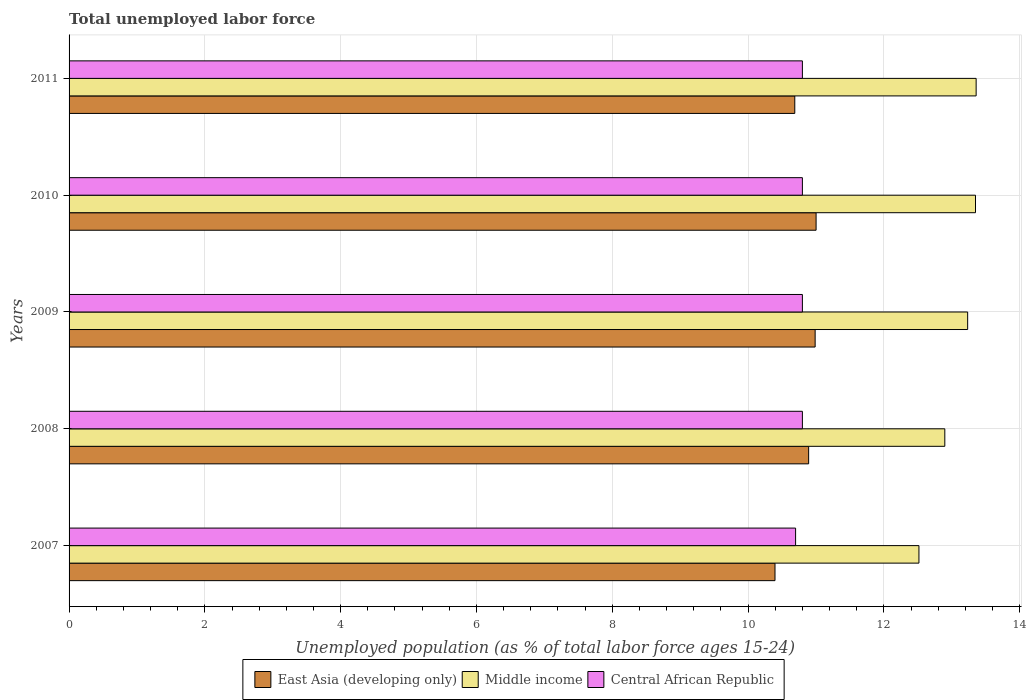How many different coloured bars are there?
Your answer should be very brief. 3. Are the number of bars on each tick of the Y-axis equal?
Offer a very short reply. Yes. How many bars are there on the 4th tick from the bottom?
Keep it short and to the point. 3. In how many cases, is the number of bars for a given year not equal to the number of legend labels?
Offer a very short reply. 0. What is the percentage of unemployed population in in Central African Republic in 2011?
Your answer should be compact. 10.8. Across all years, what is the maximum percentage of unemployed population in in East Asia (developing only)?
Your answer should be compact. 11. Across all years, what is the minimum percentage of unemployed population in in East Asia (developing only)?
Provide a succinct answer. 10.4. In which year was the percentage of unemployed population in in Central African Republic maximum?
Your answer should be very brief. 2008. In which year was the percentage of unemployed population in in Central African Republic minimum?
Keep it short and to the point. 2007. What is the total percentage of unemployed population in in Middle income in the graph?
Provide a short and direct response. 65.36. What is the difference between the percentage of unemployed population in in East Asia (developing only) in 2007 and that in 2008?
Provide a succinct answer. -0.5. What is the difference between the percentage of unemployed population in in Middle income in 2010 and the percentage of unemployed population in in Central African Republic in 2009?
Provide a short and direct response. 2.55. What is the average percentage of unemployed population in in Central African Republic per year?
Your response must be concise. 10.78. In the year 2007, what is the difference between the percentage of unemployed population in in Middle income and percentage of unemployed population in in Central African Republic?
Offer a terse response. 1.82. What is the ratio of the percentage of unemployed population in in Central African Republic in 2007 to that in 2010?
Offer a very short reply. 0.99. Is the percentage of unemployed population in in East Asia (developing only) in 2008 less than that in 2011?
Provide a succinct answer. No. What is the difference between the highest and the second highest percentage of unemployed population in in Middle income?
Ensure brevity in your answer.  0.01. What is the difference between the highest and the lowest percentage of unemployed population in in Middle income?
Make the answer very short. 0.84. What does the 3rd bar from the top in 2010 represents?
Your answer should be very brief. East Asia (developing only). What does the 2nd bar from the bottom in 2011 represents?
Keep it short and to the point. Middle income. How many bars are there?
Give a very brief answer. 15. Are all the bars in the graph horizontal?
Make the answer very short. Yes. What is the difference between two consecutive major ticks on the X-axis?
Provide a short and direct response. 2. Does the graph contain any zero values?
Offer a terse response. No. Where does the legend appear in the graph?
Give a very brief answer. Bottom center. How are the legend labels stacked?
Give a very brief answer. Horizontal. What is the title of the graph?
Give a very brief answer. Total unemployed labor force. What is the label or title of the X-axis?
Your answer should be compact. Unemployed population (as % of total labor force ages 15-24). What is the label or title of the Y-axis?
Give a very brief answer. Years. What is the Unemployed population (as % of total labor force ages 15-24) of East Asia (developing only) in 2007?
Make the answer very short. 10.4. What is the Unemployed population (as % of total labor force ages 15-24) of Middle income in 2007?
Keep it short and to the point. 12.52. What is the Unemployed population (as % of total labor force ages 15-24) of Central African Republic in 2007?
Give a very brief answer. 10.7. What is the Unemployed population (as % of total labor force ages 15-24) of East Asia (developing only) in 2008?
Your answer should be very brief. 10.89. What is the Unemployed population (as % of total labor force ages 15-24) in Middle income in 2008?
Offer a terse response. 12.9. What is the Unemployed population (as % of total labor force ages 15-24) of Central African Republic in 2008?
Your answer should be compact. 10.8. What is the Unemployed population (as % of total labor force ages 15-24) in East Asia (developing only) in 2009?
Your answer should be compact. 10.99. What is the Unemployed population (as % of total labor force ages 15-24) of Middle income in 2009?
Provide a short and direct response. 13.23. What is the Unemployed population (as % of total labor force ages 15-24) in Central African Republic in 2009?
Make the answer very short. 10.8. What is the Unemployed population (as % of total labor force ages 15-24) in East Asia (developing only) in 2010?
Provide a short and direct response. 11. What is the Unemployed population (as % of total labor force ages 15-24) in Middle income in 2010?
Make the answer very short. 13.35. What is the Unemployed population (as % of total labor force ages 15-24) in Central African Republic in 2010?
Offer a very short reply. 10.8. What is the Unemployed population (as % of total labor force ages 15-24) of East Asia (developing only) in 2011?
Your answer should be very brief. 10.69. What is the Unemployed population (as % of total labor force ages 15-24) of Middle income in 2011?
Keep it short and to the point. 13.36. What is the Unemployed population (as % of total labor force ages 15-24) in Central African Republic in 2011?
Give a very brief answer. 10.8. Across all years, what is the maximum Unemployed population (as % of total labor force ages 15-24) in East Asia (developing only)?
Ensure brevity in your answer.  11. Across all years, what is the maximum Unemployed population (as % of total labor force ages 15-24) in Middle income?
Give a very brief answer. 13.36. Across all years, what is the maximum Unemployed population (as % of total labor force ages 15-24) in Central African Republic?
Offer a very short reply. 10.8. Across all years, what is the minimum Unemployed population (as % of total labor force ages 15-24) in East Asia (developing only)?
Provide a short and direct response. 10.4. Across all years, what is the minimum Unemployed population (as % of total labor force ages 15-24) of Middle income?
Ensure brevity in your answer.  12.52. Across all years, what is the minimum Unemployed population (as % of total labor force ages 15-24) in Central African Republic?
Provide a succinct answer. 10.7. What is the total Unemployed population (as % of total labor force ages 15-24) in East Asia (developing only) in the graph?
Make the answer very short. 53.97. What is the total Unemployed population (as % of total labor force ages 15-24) of Middle income in the graph?
Keep it short and to the point. 65.36. What is the total Unemployed population (as % of total labor force ages 15-24) of Central African Republic in the graph?
Ensure brevity in your answer.  53.9. What is the difference between the Unemployed population (as % of total labor force ages 15-24) of East Asia (developing only) in 2007 and that in 2008?
Ensure brevity in your answer.  -0.5. What is the difference between the Unemployed population (as % of total labor force ages 15-24) of Middle income in 2007 and that in 2008?
Offer a very short reply. -0.38. What is the difference between the Unemployed population (as % of total labor force ages 15-24) in East Asia (developing only) in 2007 and that in 2009?
Offer a terse response. -0.59. What is the difference between the Unemployed population (as % of total labor force ages 15-24) of Middle income in 2007 and that in 2009?
Offer a very short reply. -0.72. What is the difference between the Unemployed population (as % of total labor force ages 15-24) of Central African Republic in 2007 and that in 2009?
Give a very brief answer. -0.1. What is the difference between the Unemployed population (as % of total labor force ages 15-24) in East Asia (developing only) in 2007 and that in 2010?
Your response must be concise. -0.61. What is the difference between the Unemployed population (as % of total labor force ages 15-24) in Middle income in 2007 and that in 2010?
Give a very brief answer. -0.83. What is the difference between the Unemployed population (as % of total labor force ages 15-24) of Central African Republic in 2007 and that in 2010?
Provide a short and direct response. -0.1. What is the difference between the Unemployed population (as % of total labor force ages 15-24) in East Asia (developing only) in 2007 and that in 2011?
Your answer should be very brief. -0.29. What is the difference between the Unemployed population (as % of total labor force ages 15-24) in Middle income in 2007 and that in 2011?
Keep it short and to the point. -0.84. What is the difference between the Unemployed population (as % of total labor force ages 15-24) of Central African Republic in 2007 and that in 2011?
Keep it short and to the point. -0.1. What is the difference between the Unemployed population (as % of total labor force ages 15-24) of East Asia (developing only) in 2008 and that in 2009?
Offer a very short reply. -0.1. What is the difference between the Unemployed population (as % of total labor force ages 15-24) in Middle income in 2008 and that in 2009?
Your answer should be compact. -0.34. What is the difference between the Unemployed population (as % of total labor force ages 15-24) in East Asia (developing only) in 2008 and that in 2010?
Your answer should be very brief. -0.11. What is the difference between the Unemployed population (as % of total labor force ages 15-24) in Middle income in 2008 and that in 2010?
Your response must be concise. -0.45. What is the difference between the Unemployed population (as % of total labor force ages 15-24) of Central African Republic in 2008 and that in 2010?
Offer a very short reply. 0. What is the difference between the Unemployed population (as % of total labor force ages 15-24) in East Asia (developing only) in 2008 and that in 2011?
Provide a succinct answer. 0.2. What is the difference between the Unemployed population (as % of total labor force ages 15-24) in Middle income in 2008 and that in 2011?
Ensure brevity in your answer.  -0.46. What is the difference between the Unemployed population (as % of total labor force ages 15-24) in East Asia (developing only) in 2009 and that in 2010?
Provide a short and direct response. -0.01. What is the difference between the Unemployed population (as % of total labor force ages 15-24) of Middle income in 2009 and that in 2010?
Your answer should be compact. -0.12. What is the difference between the Unemployed population (as % of total labor force ages 15-24) in Central African Republic in 2009 and that in 2010?
Provide a short and direct response. 0. What is the difference between the Unemployed population (as % of total labor force ages 15-24) in East Asia (developing only) in 2009 and that in 2011?
Provide a succinct answer. 0.3. What is the difference between the Unemployed population (as % of total labor force ages 15-24) in Middle income in 2009 and that in 2011?
Offer a very short reply. -0.12. What is the difference between the Unemployed population (as % of total labor force ages 15-24) of Central African Republic in 2009 and that in 2011?
Your answer should be very brief. 0. What is the difference between the Unemployed population (as % of total labor force ages 15-24) of East Asia (developing only) in 2010 and that in 2011?
Make the answer very short. 0.31. What is the difference between the Unemployed population (as % of total labor force ages 15-24) of Middle income in 2010 and that in 2011?
Offer a very short reply. -0.01. What is the difference between the Unemployed population (as % of total labor force ages 15-24) of Central African Republic in 2010 and that in 2011?
Offer a very short reply. 0. What is the difference between the Unemployed population (as % of total labor force ages 15-24) in East Asia (developing only) in 2007 and the Unemployed population (as % of total labor force ages 15-24) in Middle income in 2008?
Ensure brevity in your answer.  -2.5. What is the difference between the Unemployed population (as % of total labor force ages 15-24) in East Asia (developing only) in 2007 and the Unemployed population (as % of total labor force ages 15-24) in Central African Republic in 2008?
Your response must be concise. -0.4. What is the difference between the Unemployed population (as % of total labor force ages 15-24) of Middle income in 2007 and the Unemployed population (as % of total labor force ages 15-24) of Central African Republic in 2008?
Your answer should be very brief. 1.72. What is the difference between the Unemployed population (as % of total labor force ages 15-24) in East Asia (developing only) in 2007 and the Unemployed population (as % of total labor force ages 15-24) in Middle income in 2009?
Provide a short and direct response. -2.84. What is the difference between the Unemployed population (as % of total labor force ages 15-24) of East Asia (developing only) in 2007 and the Unemployed population (as % of total labor force ages 15-24) of Central African Republic in 2009?
Ensure brevity in your answer.  -0.4. What is the difference between the Unemployed population (as % of total labor force ages 15-24) in Middle income in 2007 and the Unemployed population (as % of total labor force ages 15-24) in Central African Republic in 2009?
Provide a short and direct response. 1.72. What is the difference between the Unemployed population (as % of total labor force ages 15-24) of East Asia (developing only) in 2007 and the Unemployed population (as % of total labor force ages 15-24) of Middle income in 2010?
Ensure brevity in your answer.  -2.95. What is the difference between the Unemployed population (as % of total labor force ages 15-24) in East Asia (developing only) in 2007 and the Unemployed population (as % of total labor force ages 15-24) in Central African Republic in 2010?
Offer a terse response. -0.4. What is the difference between the Unemployed population (as % of total labor force ages 15-24) of Middle income in 2007 and the Unemployed population (as % of total labor force ages 15-24) of Central African Republic in 2010?
Provide a succinct answer. 1.72. What is the difference between the Unemployed population (as % of total labor force ages 15-24) of East Asia (developing only) in 2007 and the Unemployed population (as % of total labor force ages 15-24) of Middle income in 2011?
Provide a succinct answer. -2.96. What is the difference between the Unemployed population (as % of total labor force ages 15-24) in East Asia (developing only) in 2007 and the Unemployed population (as % of total labor force ages 15-24) in Central African Republic in 2011?
Offer a very short reply. -0.4. What is the difference between the Unemployed population (as % of total labor force ages 15-24) of Middle income in 2007 and the Unemployed population (as % of total labor force ages 15-24) of Central African Republic in 2011?
Offer a terse response. 1.72. What is the difference between the Unemployed population (as % of total labor force ages 15-24) of East Asia (developing only) in 2008 and the Unemployed population (as % of total labor force ages 15-24) of Middle income in 2009?
Make the answer very short. -2.34. What is the difference between the Unemployed population (as % of total labor force ages 15-24) in East Asia (developing only) in 2008 and the Unemployed population (as % of total labor force ages 15-24) in Central African Republic in 2009?
Make the answer very short. 0.09. What is the difference between the Unemployed population (as % of total labor force ages 15-24) of Middle income in 2008 and the Unemployed population (as % of total labor force ages 15-24) of Central African Republic in 2009?
Your response must be concise. 2.1. What is the difference between the Unemployed population (as % of total labor force ages 15-24) in East Asia (developing only) in 2008 and the Unemployed population (as % of total labor force ages 15-24) in Middle income in 2010?
Provide a short and direct response. -2.46. What is the difference between the Unemployed population (as % of total labor force ages 15-24) of East Asia (developing only) in 2008 and the Unemployed population (as % of total labor force ages 15-24) of Central African Republic in 2010?
Keep it short and to the point. 0.09. What is the difference between the Unemployed population (as % of total labor force ages 15-24) of Middle income in 2008 and the Unemployed population (as % of total labor force ages 15-24) of Central African Republic in 2010?
Give a very brief answer. 2.1. What is the difference between the Unemployed population (as % of total labor force ages 15-24) of East Asia (developing only) in 2008 and the Unemployed population (as % of total labor force ages 15-24) of Middle income in 2011?
Make the answer very short. -2.47. What is the difference between the Unemployed population (as % of total labor force ages 15-24) of East Asia (developing only) in 2008 and the Unemployed population (as % of total labor force ages 15-24) of Central African Republic in 2011?
Ensure brevity in your answer.  0.09. What is the difference between the Unemployed population (as % of total labor force ages 15-24) in Middle income in 2008 and the Unemployed population (as % of total labor force ages 15-24) in Central African Republic in 2011?
Ensure brevity in your answer.  2.1. What is the difference between the Unemployed population (as % of total labor force ages 15-24) in East Asia (developing only) in 2009 and the Unemployed population (as % of total labor force ages 15-24) in Middle income in 2010?
Offer a terse response. -2.36. What is the difference between the Unemployed population (as % of total labor force ages 15-24) in East Asia (developing only) in 2009 and the Unemployed population (as % of total labor force ages 15-24) in Central African Republic in 2010?
Offer a terse response. 0.19. What is the difference between the Unemployed population (as % of total labor force ages 15-24) in Middle income in 2009 and the Unemployed population (as % of total labor force ages 15-24) in Central African Republic in 2010?
Give a very brief answer. 2.43. What is the difference between the Unemployed population (as % of total labor force ages 15-24) of East Asia (developing only) in 2009 and the Unemployed population (as % of total labor force ages 15-24) of Middle income in 2011?
Offer a terse response. -2.37. What is the difference between the Unemployed population (as % of total labor force ages 15-24) in East Asia (developing only) in 2009 and the Unemployed population (as % of total labor force ages 15-24) in Central African Republic in 2011?
Your response must be concise. 0.19. What is the difference between the Unemployed population (as % of total labor force ages 15-24) in Middle income in 2009 and the Unemployed population (as % of total labor force ages 15-24) in Central African Republic in 2011?
Offer a very short reply. 2.43. What is the difference between the Unemployed population (as % of total labor force ages 15-24) in East Asia (developing only) in 2010 and the Unemployed population (as % of total labor force ages 15-24) in Middle income in 2011?
Give a very brief answer. -2.36. What is the difference between the Unemployed population (as % of total labor force ages 15-24) in East Asia (developing only) in 2010 and the Unemployed population (as % of total labor force ages 15-24) in Central African Republic in 2011?
Ensure brevity in your answer.  0.2. What is the difference between the Unemployed population (as % of total labor force ages 15-24) in Middle income in 2010 and the Unemployed population (as % of total labor force ages 15-24) in Central African Republic in 2011?
Provide a short and direct response. 2.55. What is the average Unemployed population (as % of total labor force ages 15-24) in East Asia (developing only) per year?
Offer a very short reply. 10.79. What is the average Unemployed population (as % of total labor force ages 15-24) in Middle income per year?
Your answer should be very brief. 13.07. What is the average Unemployed population (as % of total labor force ages 15-24) of Central African Republic per year?
Give a very brief answer. 10.78. In the year 2007, what is the difference between the Unemployed population (as % of total labor force ages 15-24) of East Asia (developing only) and Unemployed population (as % of total labor force ages 15-24) of Middle income?
Offer a terse response. -2.12. In the year 2007, what is the difference between the Unemployed population (as % of total labor force ages 15-24) in East Asia (developing only) and Unemployed population (as % of total labor force ages 15-24) in Central African Republic?
Keep it short and to the point. -0.3. In the year 2007, what is the difference between the Unemployed population (as % of total labor force ages 15-24) in Middle income and Unemployed population (as % of total labor force ages 15-24) in Central African Republic?
Provide a short and direct response. 1.82. In the year 2008, what is the difference between the Unemployed population (as % of total labor force ages 15-24) of East Asia (developing only) and Unemployed population (as % of total labor force ages 15-24) of Middle income?
Your response must be concise. -2.01. In the year 2008, what is the difference between the Unemployed population (as % of total labor force ages 15-24) in East Asia (developing only) and Unemployed population (as % of total labor force ages 15-24) in Central African Republic?
Make the answer very short. 0.09. In the year 2008, what is the difference between the Unemployed population (as % of total labor force ages 15-24) in Middle income and Unemployed population (as % of total labor force ages 15-24) in Central African Republic?
Offer a very short reply. 2.1. In the year 2009, what is the difference between the Unemployed population (as % of total labor force ages 15-24) in East Asia (developing only) and Unemployed population (as % of total labor force ages 15-24) in Middle income?
Offer a very short reply. -2.25. In the year 2009, what is the difference between the Unemployed population (as % of total labor force ages 15-24) in East Asia (developing only) and Unemployed population (as % of total labor force ages 15-24) in Central African Republic?
Keep it short and to the point. 0.19. In the year 2009, what is the difference between the Unemployed population (as % of total labor force ages 15-24) in Middle income and Unemployed population (as % of total labor force ages 15-24) in Central African Republic?
Your response must be concise. 2.43. In the year 2010, what is the difference between the Unemployed population (as % of total labor force ages 15-24) of East Asia (developing only) and Unemployed population (as % of total labor force ages 15-24) of Middle income?
Give a very brief answer. -2.35. In the year 2010, what is the difference between the Unemployed population (as % of total labor force ages 15-24) in East Asia (developing only) and Unemployed population (as % of total labor force ages 15-24) in Central African Republic?
Give a very brief answer. 0.2. In the year 2010, what is the difference between the Unemployed population (as % of total labor force ages 15-24) of Middle income and Unemployed population (as % of total labor force ages 15-24) of Central African Republic?
Offer a very short reply. 2.55. In the year 2011, what is the difference between the Unemployed population (as % of total labor force ages 15-24) in East Asia (developing only) and Unemployed population (as % of total labor force ages 15-24) in Middle income?
Give a very brief answer. -2.67. In the year 2011, what is the difference between the Unemployed population (as % of total labor force ages 15-24) in East Asia (developing only) and Unemployed population (as % of total labor force ages 15-24) in Central African Republic?
Ensure brevity in your answer.  -0.11. In the year 2011, what is the difference between the Unemployed population (as % of total labor force ages 15-24) in Middle income and Unemployed population (as % of total labor force ages 15-24) in Central African Republic?
Offer a terse response. 2.56. What is the ratio of the Unemployed population (as % of total labor force ages 15-24) in East Asia (developing only) in 2007 to that in 2008?
Provide a succinct answer. 0.95. What is the ratio of the Unemployed population (as % of total labor force ages 15-24) in Middle income in 2007 to that in 2008?
Your answer should be compact. 0.97. What is the ratio of the Unemployed population (as % of total labor force ages 15-24) of Central African Republic in 2007 to that in 2008?
Offer a very short reply. 0.99. What is the ratio of the Unemployed population (as % of total labor force ages 15-24) in East Asia (developing only) in 2007 to that in 2009?
Give a very brief answer. 0.95. What is the ratio of the Unemployed population (as % of total labor force ages 15-24) in Middle income in 2007 to that in 2009?
Offer a terse response. 0.95. What is the ratio of the Unemployed population (as % of total labor force ages 15-24) in Central African Republic in 2007 to that in 2009?
Your answer should be compact. 0.99. What is the ratio of the Unemployed population (as % of total labor force ages 15-24) in East Asia (developing only) in 2007 to that in 2010?
Your answer should be very brief. 0.94. What is the ratio of the Unemployed population (as % of total labor force ages 15-24) of Middle income in 2007 to that in 2010?
Your response must be concise. 0.94. What is the ratio of the Unemployed population (as % of total labor force ages 15-24) in Central African Republic in 2007 to that in 2010?
Make the answer very short. 0.99. What is the ratio of the Unemployed population (as % of total labor force ages 15-24) in East Asia (developing only) in 2007 to that in 2011?
Your answer should be very brief. 0.97. What is the ratio of the Unemployed population (as % of total labor force ages 15-24) in Middle income in 2007 to that in 2011?
Offer a very short reply. 0.94. What is the ratio of the Unemployed population (as % of total labor force ages 15-24) in East Asia (developing only) in 2008 to that in 2009?
Provide a succinct answer. 0.99. What is the ratio of the Unemployed population (as % of total labor force ages 15-24) of Middle income in 2008 to that in 2009?
Keep it short and to the point. 0.97. What is the ratio of the Unemployed population (as % of total labor force ages 15-24) in Middle income in 2008 to that in 2010?
Your response must be concise. 0.97. What is the ratio of the Unemployed population (as % of total labor force ages 15-24) in Central African Republic in 2008 to that in 2010?
Provide a succinct answer. 1. What is the ratio of the Unemployed population (as % of total labor force ages 15-24) in East Asia (developing only) in 2008 to that in 2011?
Your answer should be very brief. 1.02. What is the ratio of the Unemployed population (as % of total labor force ages 15-24) of Middle income in 2008 to that in 2011?
Give a very brief answer. 0.97. What is the ratio of the Unemployed population (as % of total labor force ages 15-24) in Central African Republic in 2008 to that in 2011?
Give a very brief answer. 1. What is the ratio of the Unemployed population (as % of total labor force ages 15-24) in East Asia (developing only) in 2009 to that in 2010?
Give a very brief answer. 1. What is the ratio of the Unemployed population (as % of total labor force ages 15-24) of Middle income in 2009 to that in 2010?
Keep it short and to the point. 0.99. What is the ratio of the Unemployed population (as % of total labor force ages 15-24) of East Asia (developing only) in 2009 to that in 2011?
Offer a terse response. 1.03. What is the ratio of the Unemployed population (as % of total labor force ages 15-24) of Middle income in 2009 to that in 2011?
Offer a very short reply. 0.99. What is the ratio of the Unemployed population (as % of total labor force ages 15-24) in Central African Republic in 2009 to that in 2011?
Make the answer very short. 1. What is the ratio of the Unemployed population (as % of total labor force ages 15-24) in East Asia (developing only) in 2010 to that in 2011?
Give a very brief answer. 1.03. What is the ratio of the Unemployed population (as % of total labor force ages 15-24) in Central African Republic in 2010 to that in 2011?
Your answer should be very brief. 1. What is the difference between the highest and the second highest Unemployed population (as % of total labor force ages 15-24) of East Asia (developing only)?
Make the answer very short. 0.01. What is the difference between the highest and the second highest Unemployed population (as % of total labor force ages 15-24) in Middle income?
Offer a terse response. 0.01. What is the difference between the highest and the lowest Unemployed population (as % of total labor force ages 15-24) in East Asia (developing only)?
Your answer should be compact. 0.61. What is the difference between the highest and the lowest Unemployed population (as % of total labor force ages 15-24) of Middle income?
Your answer should be compact. 0.84. What is the difference between the highest and the lowest Unemployed population (as % of total labor force ages 15-24) in Central African Republic?
Make the answer very short. 0.1. 